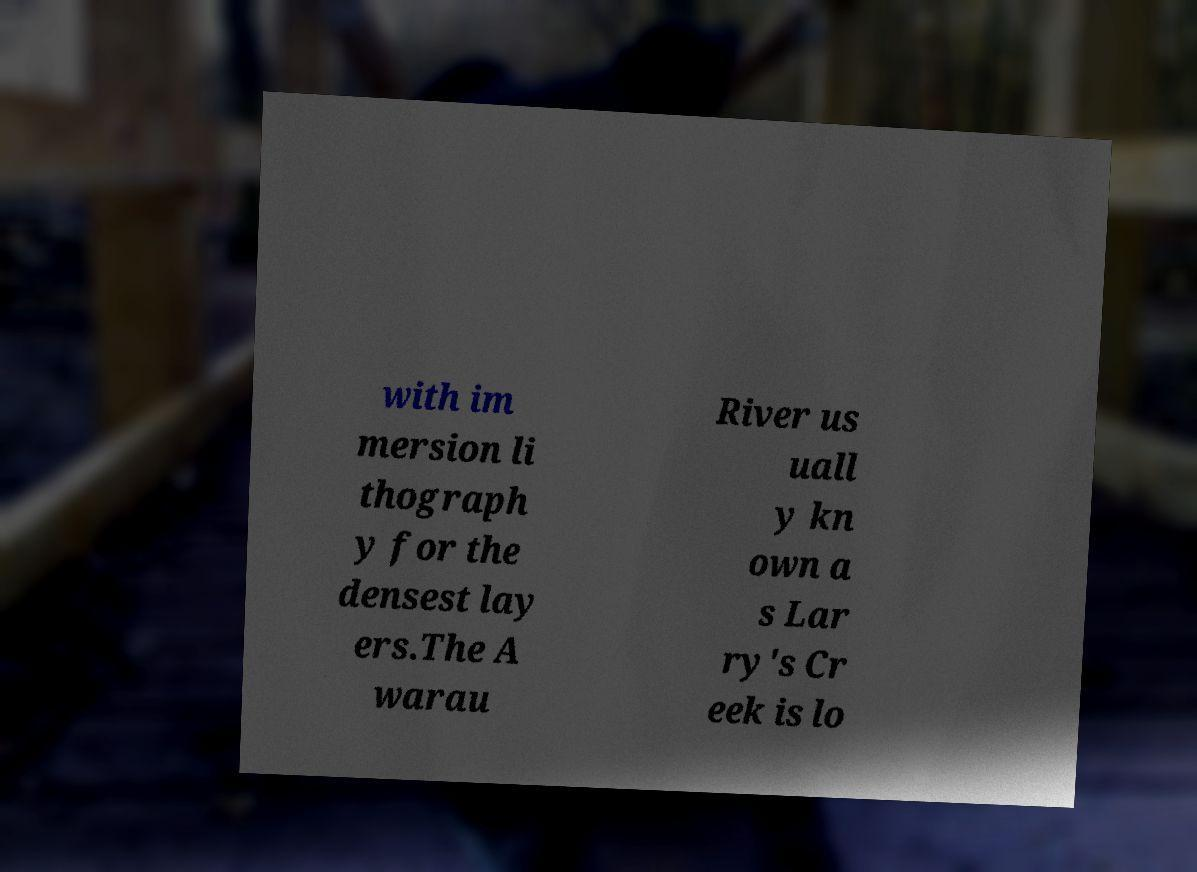I need the written content from this picture converted into text. Can you do that? with im mersion li thograph y for the densest lay ers.The A warau River us uall y kn own a s Lar ry's Cr eek is lo 